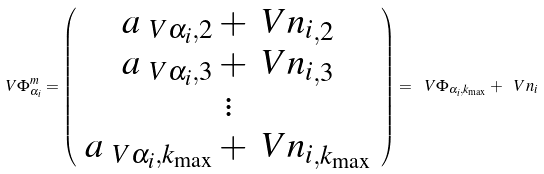<formula> <loc_0><loc_0><loc_500><loc_500>\ V { \Phi ^ { m } _ { \alpha _ { i } } } = \left ( \begin{array} { c } a _ { \ V { \alpha _ { i } } , 2 } + \ V { n _ { i } } _ { , 2 } \\ a _ { \ V { \alpha _ { i } } , 3 } + \ V { n _ { i } } _ { , 3 } \\ \vdots \\ a _ { \ V { \alpha _ { i } } , k _ { \max } } + \ V { n _ { i } } _ { , k _ { \max } } \end{array} \right ) = \ V { \Phi _ { \alpha _ { i } , k _ { \max } } } + \ V { n _ { i } }</formula> 